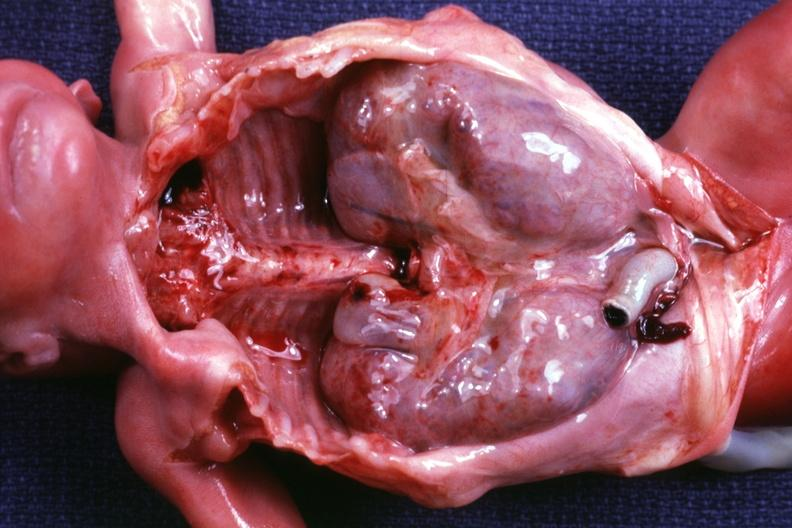s other organs removed dramatic demonstration of size of kidneys?
Answer the question using a single word or phrase. Yes 